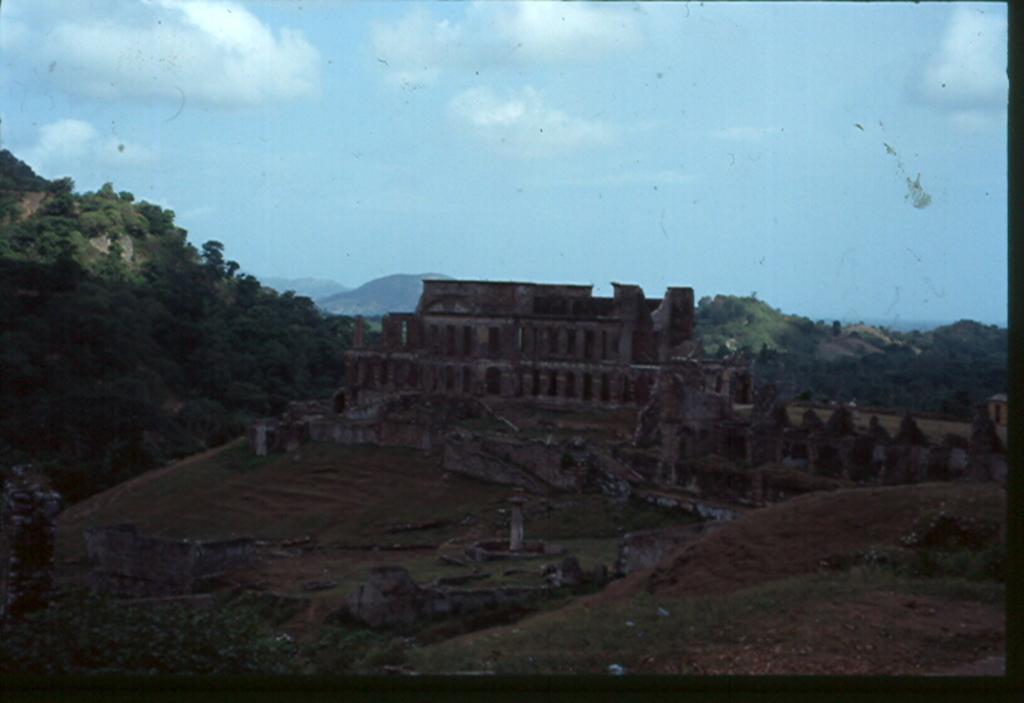Describe this image in one or two sentences. In this picture I can see a fort, and in the background there are trees, hills and the sky. 